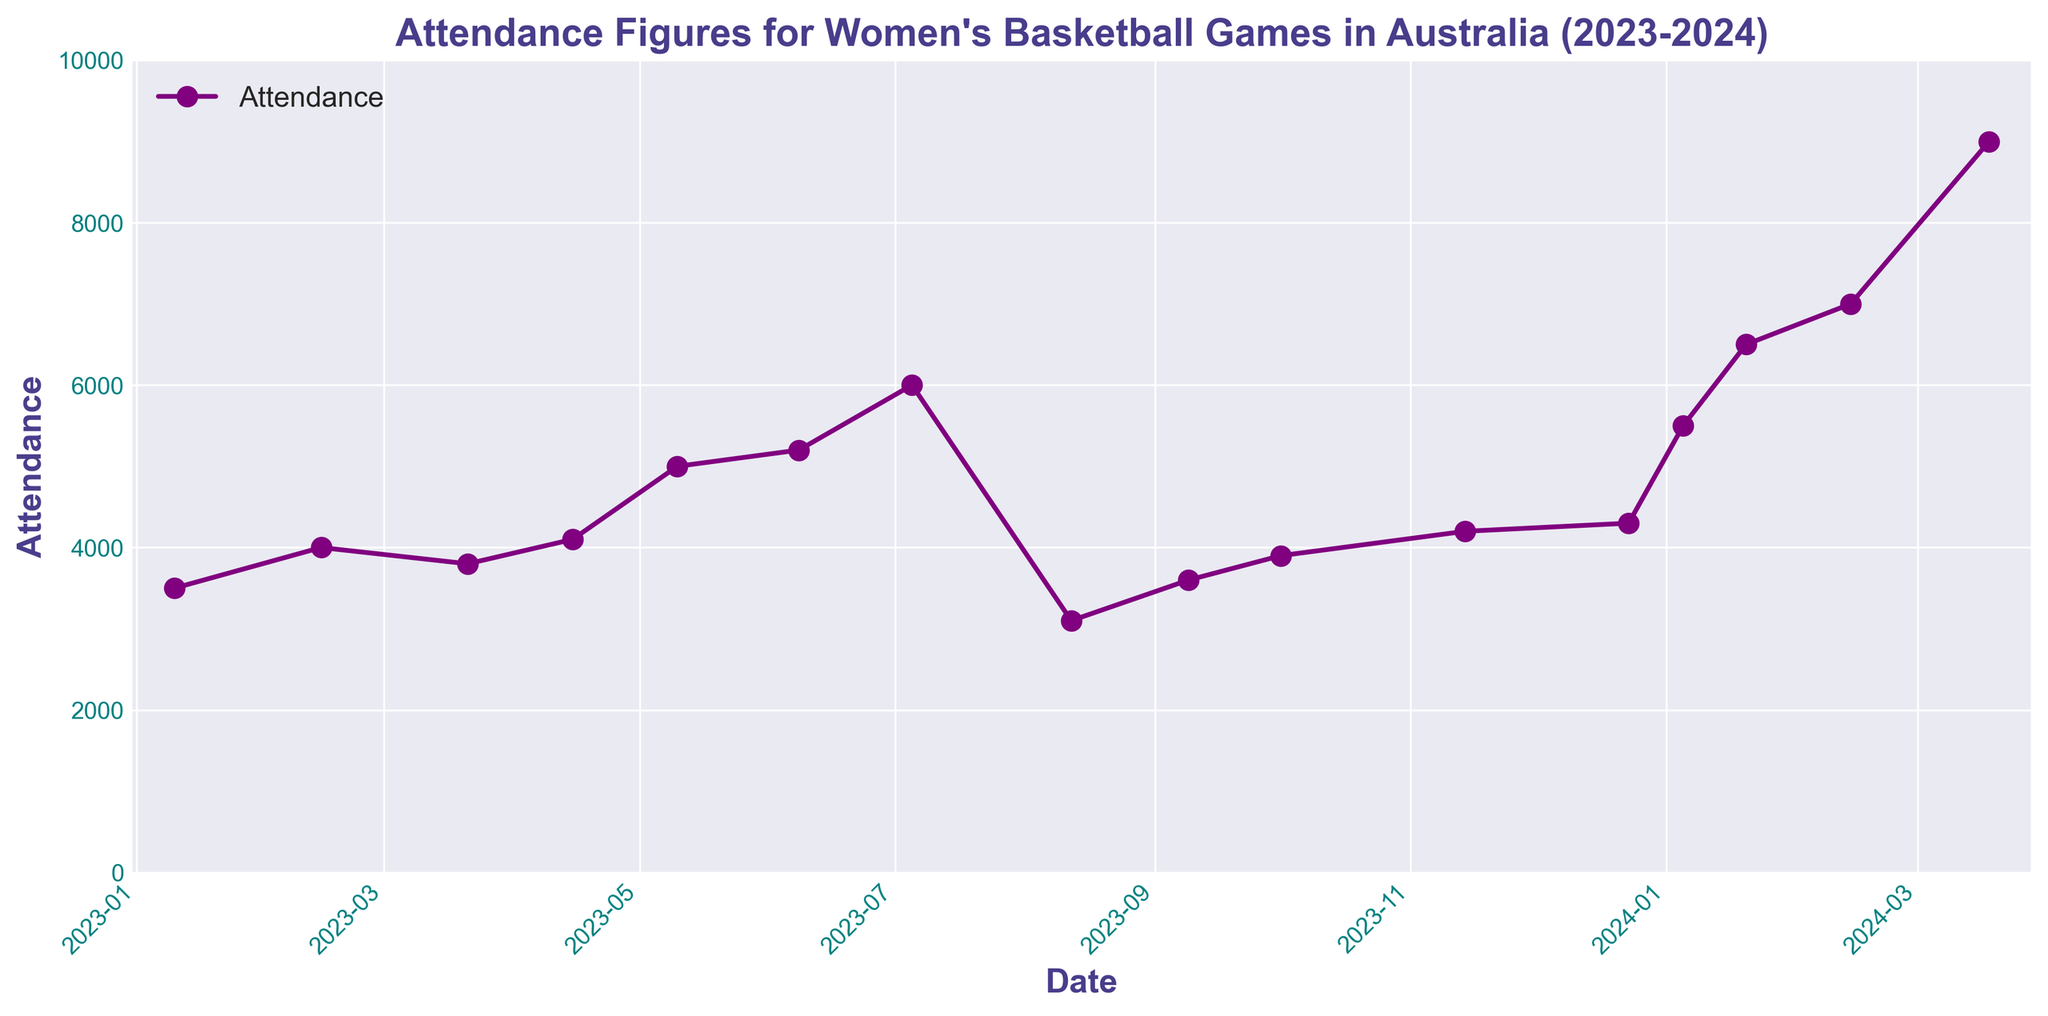What was the attendance for the International Friendly on July 5, 2023? The attendance for the International Friendly on July 5, 2023, can be found by locating the date on the x-axis and checking the corresponding y-axis value.
Answer: 6000 Which event had the highest attendance, and what was the attendance figure? To determine the event with the highest attendance, look for the peak on the chart and identify the corresponding event on the x-axis and the y-axis value at that peak.
Answer: FIBA World Cup Finals, 9000 By how much did attendance increase from the WNBL Finals on January 20, 2024, to the FIBA World Cup Qualifiers on February 14, 2024? Identify the attendance values for the WNBL Finals (6500) and the FIBA World Cup Qualifiers (7000). Calculate the difference by subtracting the former from the latter: 7000 - 6500
Answer: 500 Which event had the lowest attendance, and what was the attendance figure? To find the event with the lowest attendance, look for the lowest point on the chart and identify the corresponding event on the x-axis and the y-axis value at that point.
Answer: WNBL Pre-season, 3100 What is the average attendance for the WNBL Playoffs games? Identify the attendance figures for the WNBL Playoffs games: May 10 (5000) and June 8 (5200). Calculate the average by summing these values and dividing by the number of games: (5000 + 5200) / 2
Answer: 5100 Was the attendance for the WNBL Semi-Finals on January 5, 2024, greater than or less than the WNBL Finals on January 20, 2024? Compare the attendance figures for the WNBL Semi-Finals (5500) and the WNBL Finals (6500).
Answer: Less than What is the median attendance for all WNBL Regular Season games in 2023? Identify the attendance figures for WNBL Regular Season games in 2023: 3500, 4000, 3800, 4100, 3600, 3900, 4200, 4300. Sort these values and find the middle one(s): 3500, 3600, 3800, 3900, 4000, 4100, 4200, 4300. The median is the average of the 4th and 5th values: (3900+4000)/2
Answer: 3950 Did the attendance for WNBL games generally increase or decrease over time in 2023? Observe the trend of the data points connected by line segments for WNBL Regular Season games in 2023 from January to December.
Answer: Increase Compare the attendance for WNBL Regular Season games in February 2023 and November 2023. Which month had higher attendance? Identify the attendance figures for February 2023 (4000) and November 2023 (4200) from the plot, then compare them.
Answer: November 2023 